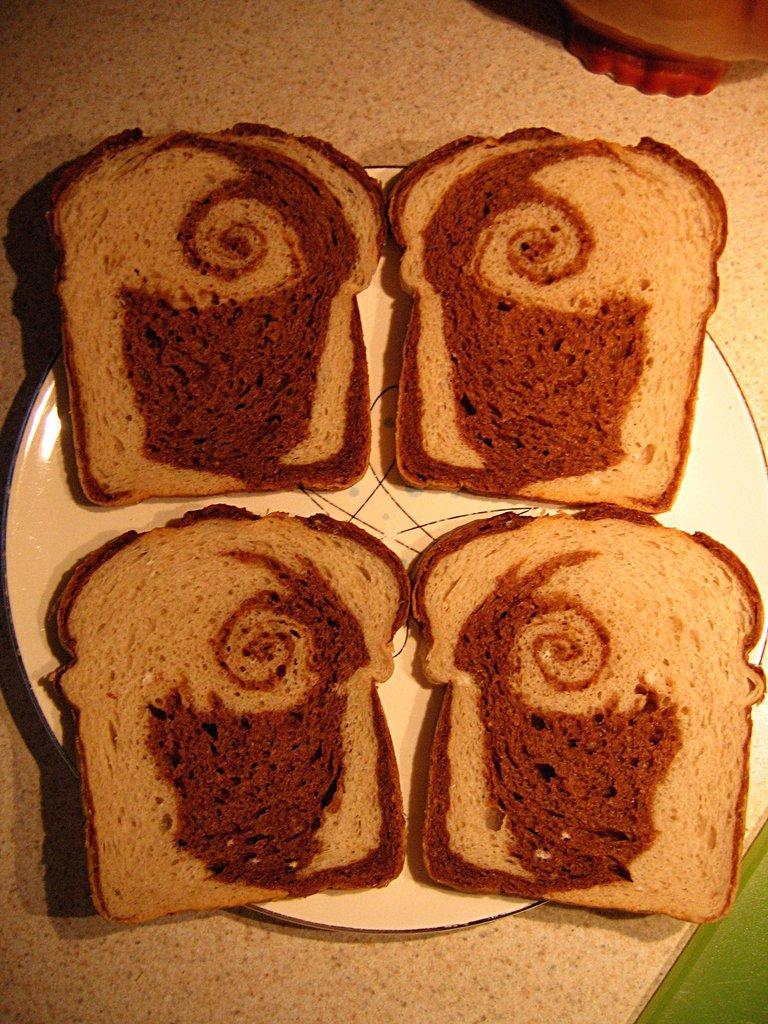Could you give a brief overview of what you see in this image? In this image, we can see food on the plate and in the background, there is an object on the table. 